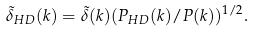<formula> <loc_0><loc_0><loc_500><loc_500>\tilde { \delta } _ { H D } ( k ) = \tilde { \delta } ( k ) ( P _ { H D } ( k ) / P ( k ) ) ^ { 1 / 2 } .</formula> 